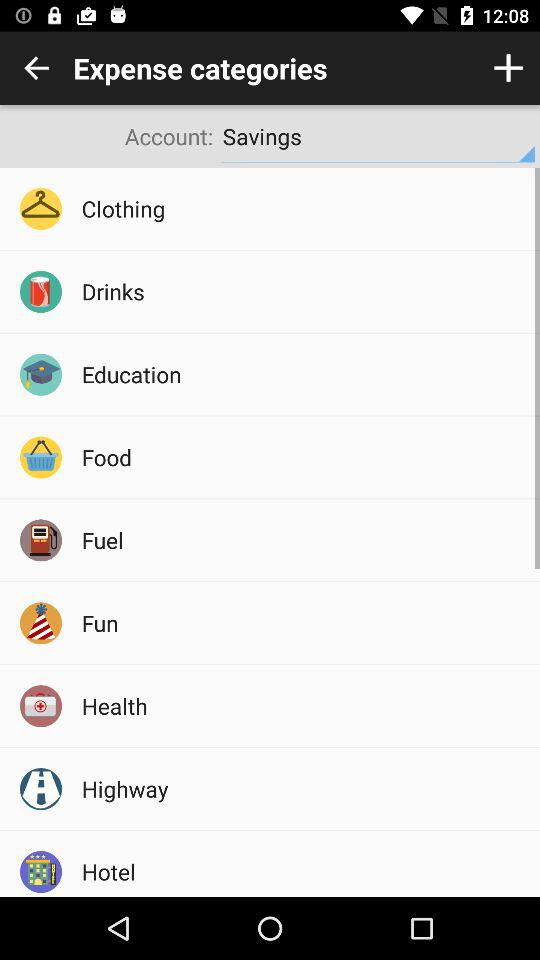Which option is selected in the "Account"? The selected option is "Savings". 